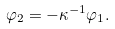Convert formula to latex. <formula><loc_0><loc_0><loc_500><loc_500>\varphi _ { 2 } = - \kappa ^ { - 1 } \varphi _ { 1 } .</formula> 